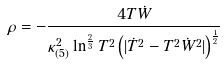Convert formula to latex. <formula><loc_0><loc_0><loc_500><loc_500>\rho = - \frac { 4 T \dot { W } } { \kappa _ { ( 5 ) } ^ { 2 } \ln ^ { \frac { 2 } { 3 } } T ^ { 2 } \left ( | \dot { T } ^ { 2 } - T ^ { 2 } \dot { W } ^ { 2 } | \right ) ^ { \frac { 1 } { 2 } } }</formula> 